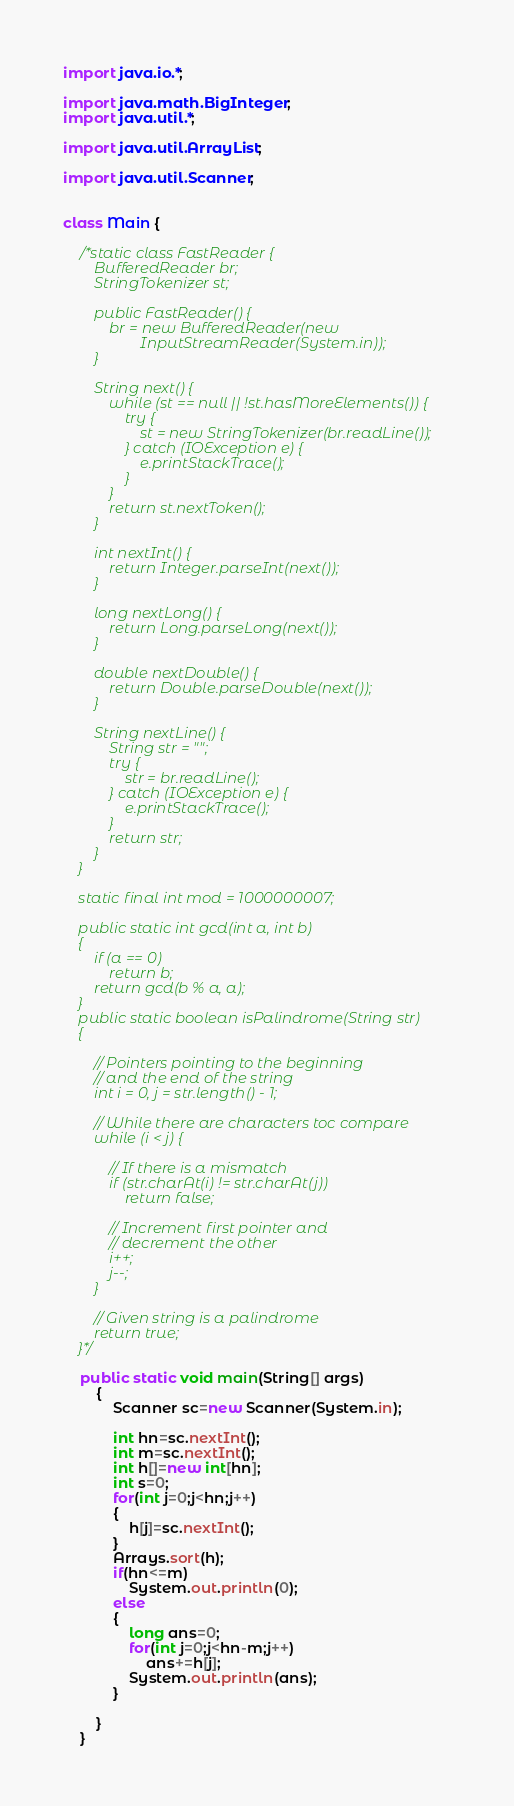<code> <loc_0><loc_0><loc_500><loc_500><_Java_>import java.io.*;

import java.math.BigInteger;
import java.util.*;

import java.util.ArrayList;

import java.util.Scanner;


class Main {

    /*static class FastReader {
        BufferedReader br;
        StringTokenizer st;

        public FastReader() {
            br = new BufferedReader(new
                    InputStreamReader(System.in));
        }

        String next() {
            while (st == null || !st.hasMoreElements()) {
                try {
                    st = new StringTokenizer(br.readLine());
                } catch (IOException e) {
                    e.printStackTrace();
                }
            }
            return st.nextToken();
        }

        int nextInt() {
            return Integer.parseInt(next());
        }

        long nextLong() {
            return Long.parseLong(next());
        }

        double nextDouble() {
            return Double.parseDouble(next());
        }

        String nextLine() {
            String str = "";
            try {
                str = br.readLine();
            } catch (IOException e) {
                e.printStackTrace();
            }
            return str;
        }
    }

    static final int mod = 1000000007;

    public static int gcd(int a, int b)
    {
        if (a == 0)
            return b;
        return gcd(b % a, a);
    }
    public static boolean isPalindrome(String str)
    {

        // Pointers pointing to the beginning
        // and the end of the string
        int i = 0, j = str.length() - 1;

        // While there are characters toc compare
        while (i < j) {

            // If there is a mismatch
            if (str.charAt(i) != str.charAt(j))
                return false;

            // Increment first pointer and
            // decrement the other
            i++;
            j--;
        }

        // Given string is a palindrome
        return true;
    }*/

    public static void main(String[] args)
        {
            Scanner sc=new Scanner(System.in);

            int hn=sc.nextInt();
            int m=sc.nextInt();
            int h[]=new int[hn];
            int s=0;
            for(int j=0;j<hn;j++)
            {
                h[j]=sc.nextInt();
            }
            Arrays.sort(h);
            if(hn<=m)
                System.out.println(0);
            else
            {
                long ans=0;
                for(int j=0;j<hn-m;j++)
                    ans+=h[j];
                System.out.println(ans);
            }

        }
    }


</code> 